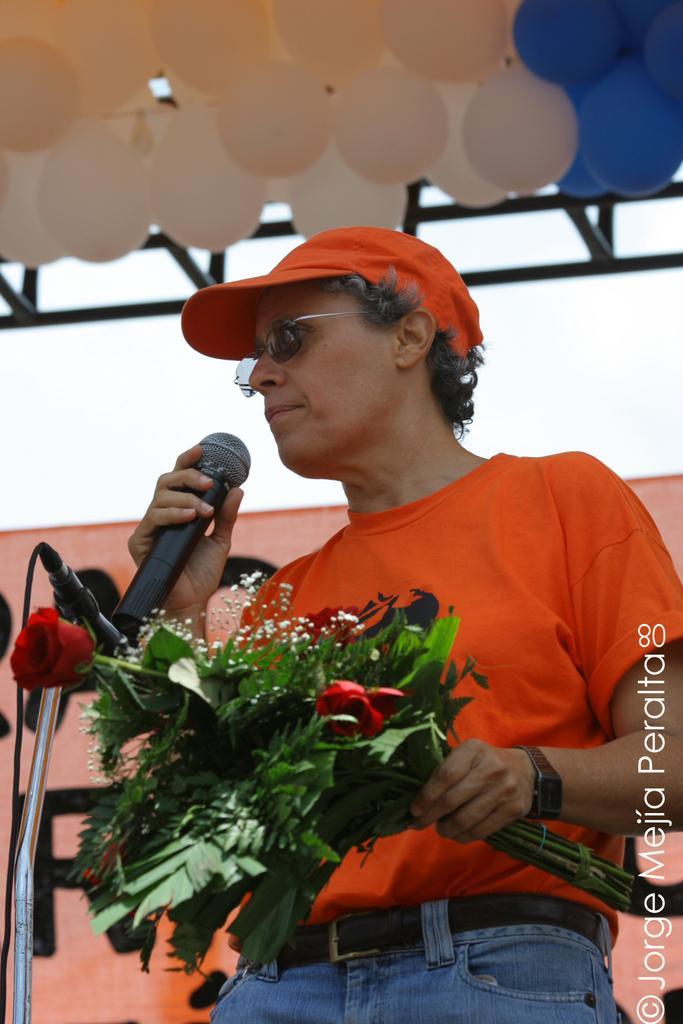In one or two sentences, can you explain what this image depicts? In this image, There is a man standing and holding a microphone and in the left hand he is holding a bunch of flowers and in the background there is a orange color curtain and in the top there are some white color and blue color balloons. 